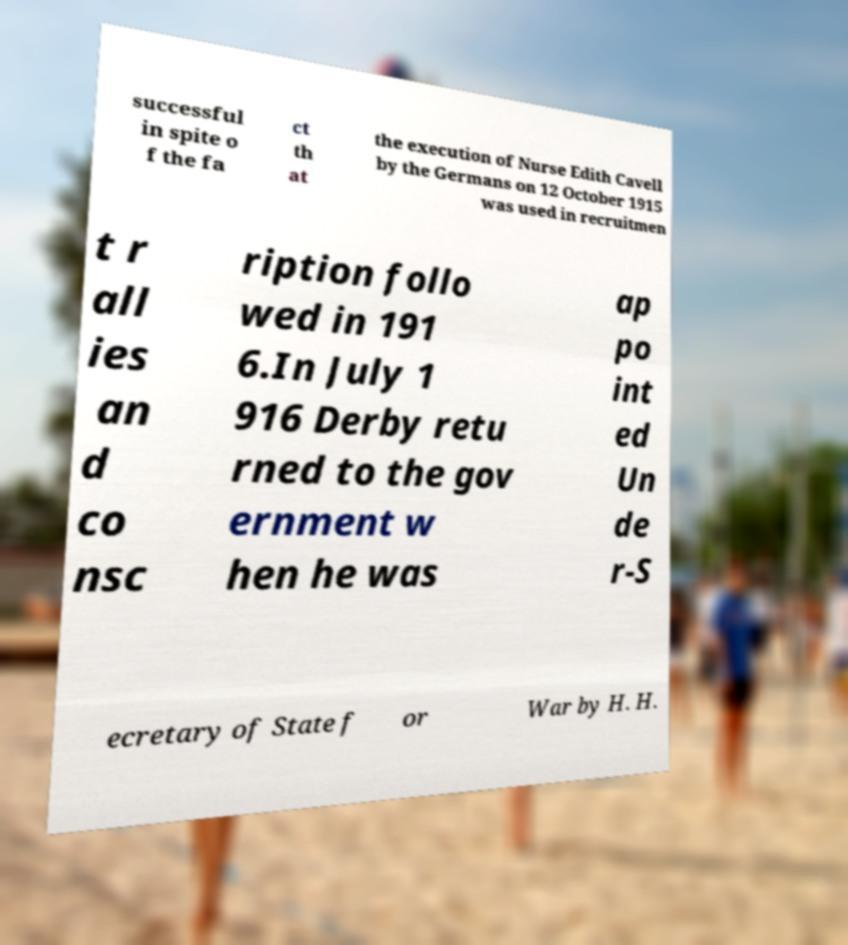Can you read and provide the text displayed in the image?This photo seems to have some interesting text. Can you extract and type it out for me? successful in spite o f the fa ct th at the execution of Nurse Edith Cavell by the Germans on 12 October 1915 was used in recruitmen t r all ies an d co nsc ription follo wed in 191 6.In July 1 916 Derby retu rned to the gov ernment w hen he was ap po int ed Un de r-S ecretary of State f or War by H. H. 